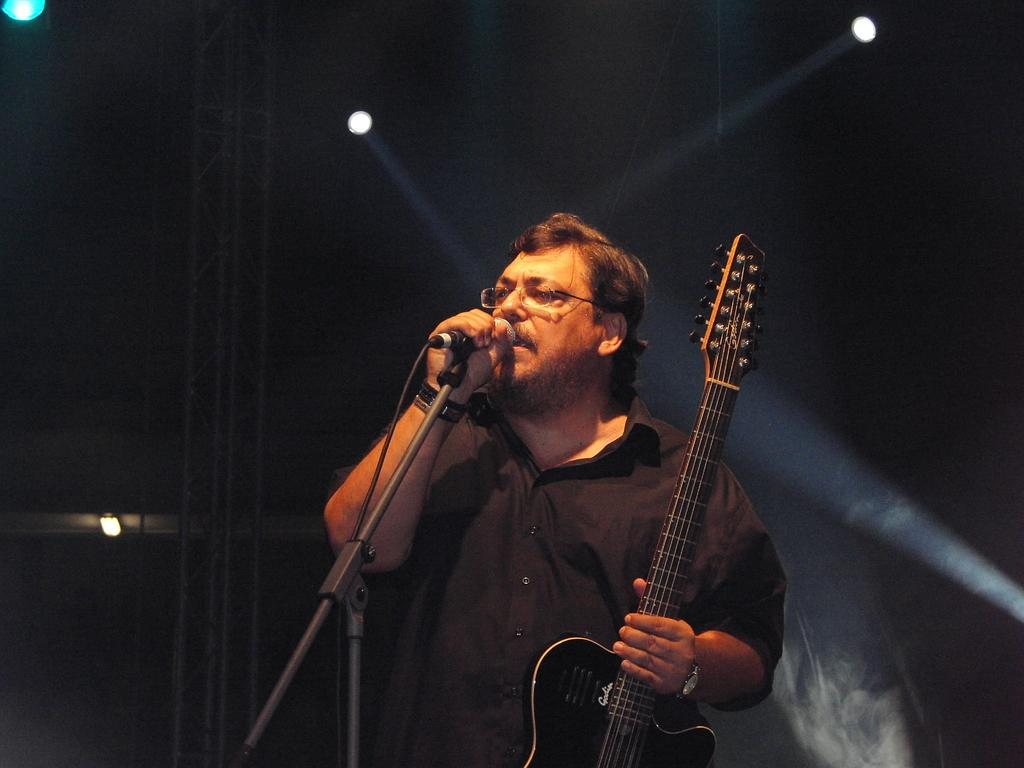Who is the main subject in the image? There is a man in the image. What is the man doing in the image? The man is singing. What instrument is the man holding in the image? The man is holding a guitar. What device is present for amplifying the man's voice? There is a microphone in the image. What type of lighting can be seen in the image? There are lights on the ceiling. What type of night theory does the man in the image subscribe to? There is no mention of a night theory or any discussion about theories in the image. The man is simply singing while holding a guitar and using a microphone. 